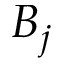<formula> <loc_0><loc_0><loc_500><loc_500>B _ { j }</formula> 